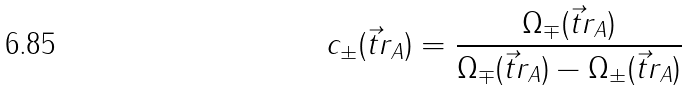<formula> <loc_0><loc_0><loc_500><loc_500>c _ { \pm } ( \vec { t } { r } _ { A } ) = \frac { \Omega _ { \mp } ( \vec { t } { r } _ { A } ) } { \Omega _ { \mp } ( \vec { t } { r } _ { A } ) - \Omega _ { \pm } ( \vec { t } { r } _ { A } ) }</formula> 